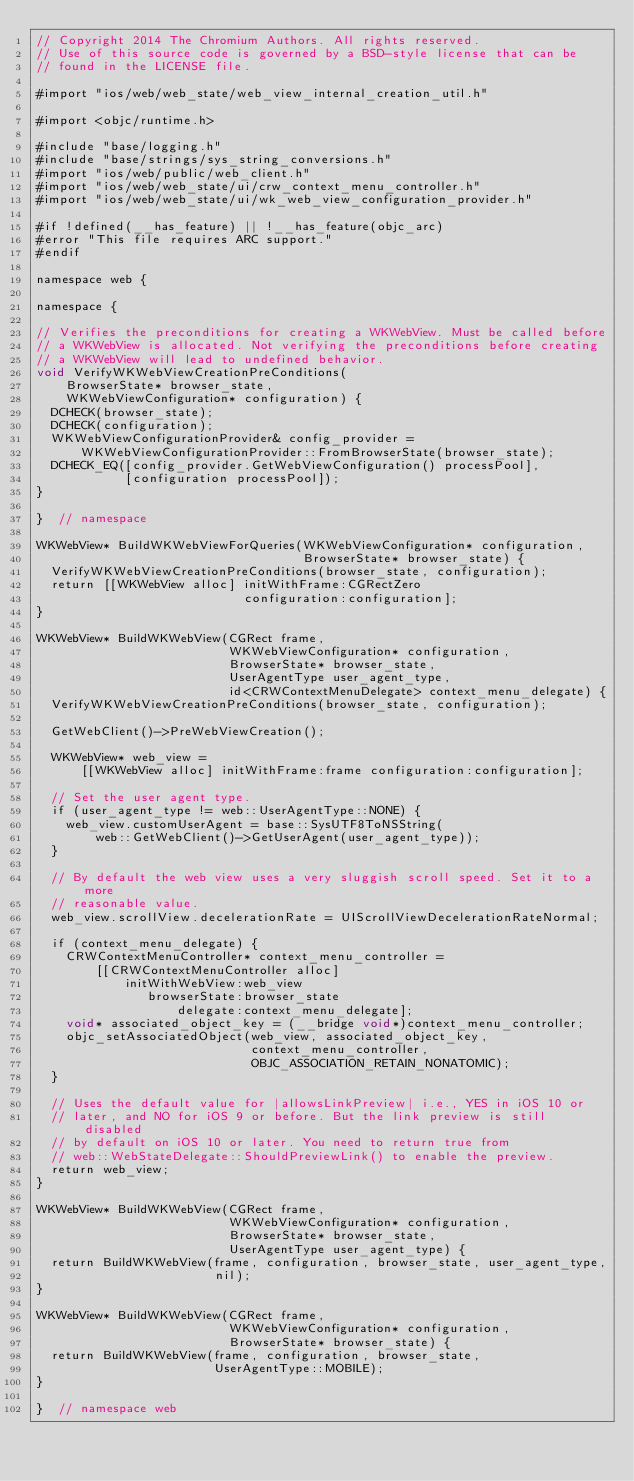Convert code to text. <code><loc_0><loc_0><loc_500><loc_500><_ObjectiveC_>// Copyright 2014 The Chromium Authors. All rights reserved.
// Use of this source code is governed by a BSD-style license that can be
// found in the LICENSE file.

#import "ios/web/web_state/web_view_internal_creation_util.h"

#import <objc/runtime.h>

#include "base/logging.h"
#include "base/strings/sys_string_conversions.h"
#import "ios/web/public/web_client.h"
#import "ios/web/web_state/ui/crw_context_menu_controller.h"
#import "ios/web/web_state/ui/wk_web_view_configuration_provider.h"

#if !defined(__has_feature) || !__has_feature(objc_arc)
#error "This file requires ARC support."
#endif

namespace web {

namespace {

// Verifies the preconditions for creating a WKWebView. Must be called before
// a WKWebView is allocated. Not verifying the preconditions before creating
// a WKWebView will lead to undefined behavior.
void VerifyWKWebViewCreationPreConditions(
    BrowserState* browser_state,
    WKWebViewConfiguration* configuration) {
  DCHECK(browser_state);
  DCHECK(configuration);
  WKWebViewConfigurationProvider& config_provider =
      WKWebViewConfigurationProvider::FromBrowserState(browser_state);
  DCHECK_EQ([config_provider.GetWebViewConfiguration() processPool],
            [configuration processPool]);
}

}  // namespace

WKWebView* BuildWKWebViewForQueries(WKWebViewConfiguration* configuration,
                                    BrowserState* browser_state) {
  VerifyWKWebViewCreationPreConditions(browser_state, configuration);
  return [[WKWebView alloc] initWithFrame:CGRectZero
                            configuration:configuration];
}

WKWebView* BuildWKWebView(CGRect frame,
                          WKWebViewConfiguration* configuration,
                          BrowserState* browser_state,
                          UserAgentType user_agent_type,
                          id<CRWContextMenuDelegate> context_menu_delegate) {
  VerifyWKWebViewCreationPreConditions(browser_state, configuration);

  GetWebClient()->PreWebViewCreation();

  WKWebView* web_view =
      [[WKWebView alloc] initWithFrame:frame configuration:configuration];

  // Set the user agent type.
  if (user_agent_type != web::UserAgentType::NONE) {
    web_view.customUserAgent = base::SysUTF8ToNSString(
        web::GetWebClient()->GetUserAgent(user_agent_type));
  }

  // By default the web view uses a very sluggish scroll speed. Set it to a more
  // reasonable value.
  web_view.scrollView.decelerationRate = UIScrollViewDecelerationRateNormal;

  if (context_menu_delegate) {
    CRWContextMenuController* context_menu_controller =
        [[CRWContextMenuController alloc]
            initWithWebView:web_view
               browserState:browser_state
                   delegate:context_menu_delegate];
    void* associated_object_key = (__bridge void*)context_menu_controller;
    objc_setAssociatedObject(web_view, associated_object_key,
                             context_menu_controller,
                             OBJC_ASSOCIATION_RETAIN_NONATOMIC);
  }

  // Uses the default value for |allowsLinkPreview| i.e., YES in iOS 10 or
  // later, and NO for iOS 9 or before. But the link preview is still disabled
  // by default on iOS 10 or later. You need to return true from
  // web::WebStateDelegate::ShouldPreviewLink() to enable the preview.
  return web_view;
}

WKWebView* BuildWKWebView(CGRect frame,
                          WKWebViewConfiguration* configuration,
                          BrowserState* browser_state,
                          UserAgentType user_agent_type) {
  return BuildWKWebView(frame, configuration, browser_state, user_agent_type,
                        nil);
}

WKWebView* BuildWKWebView(CGRect frame,
                          WKWebViewConfiguration* configuration,
                          BrowserState* browser_state) {
  return BuildWKWebView(frame, configuration, browser_state,
                        UserAgentType::MOBILE);
}

}  // namespace web
</code> 